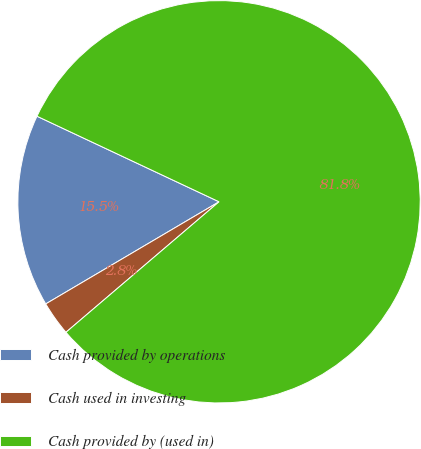Convert chart. <chart><loc_0><loc_0><loc_500><loc_500><pie_chart><fcel>Cash provided by operations<fcel>Cash used in investing<fcel>Cash provided by (used in)<nl><fcel>15.47%<fcel>2.76%<fcel>81.77%<nl></chart> 